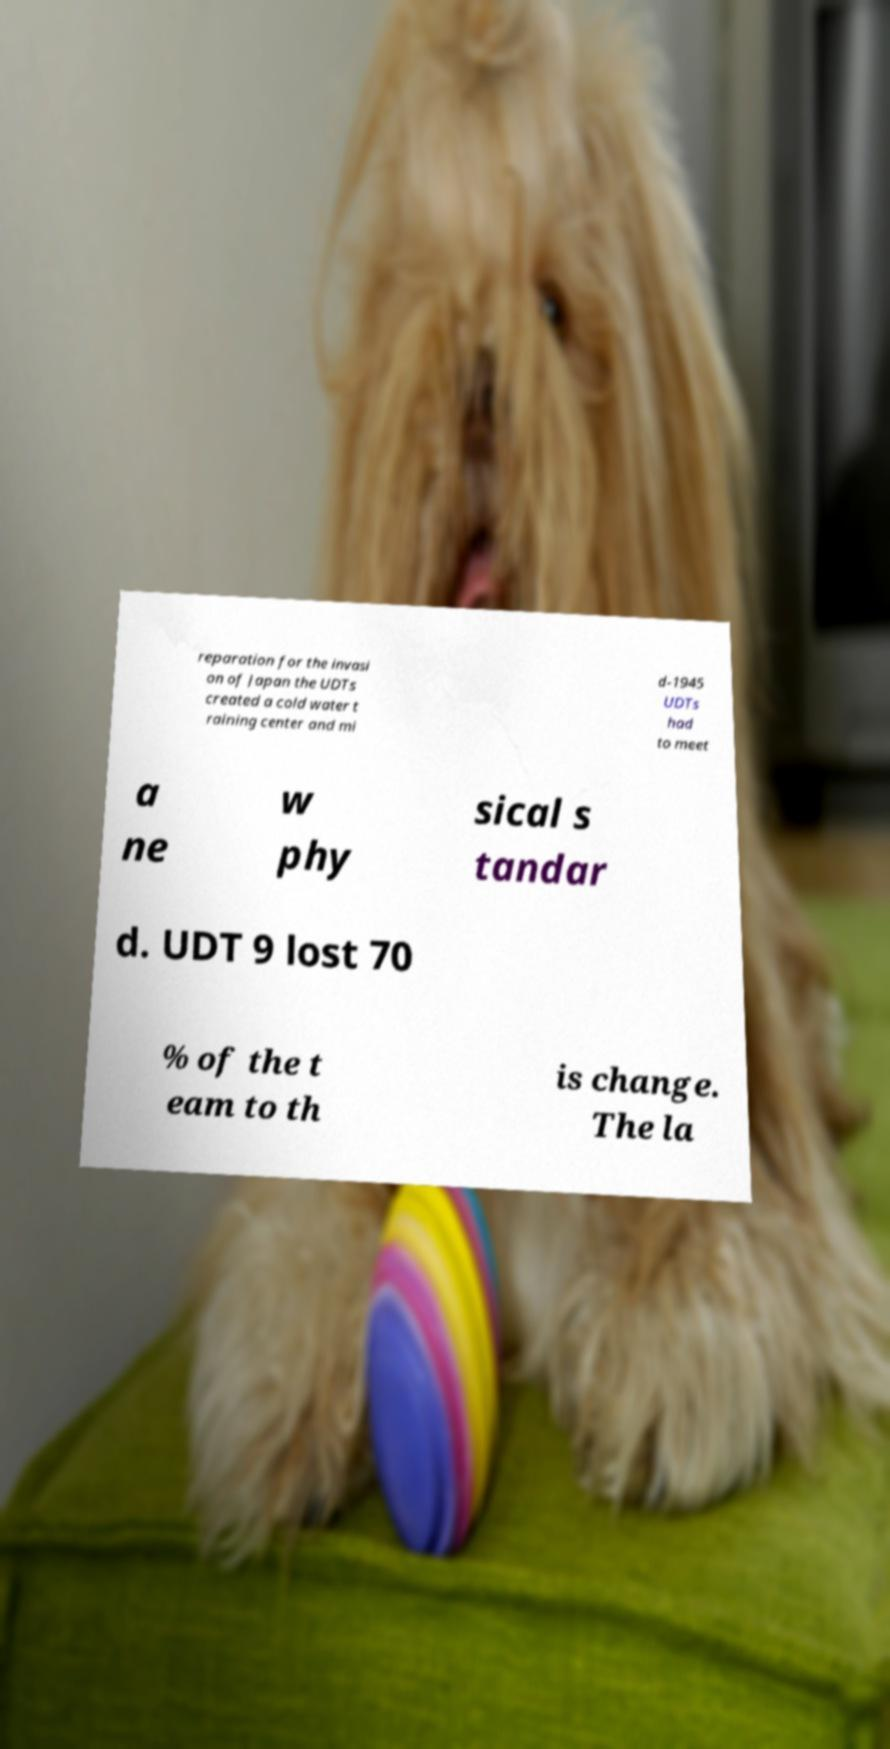Could you extract and type out the text from this image? reparation for the invasi on of Japan the UDTs created a cold water t raining center and mi d-1945 UDTs had to meet a ne w phy sical s tandar d. UDT 9 lost 70 % of the t eam to th is change. The la 